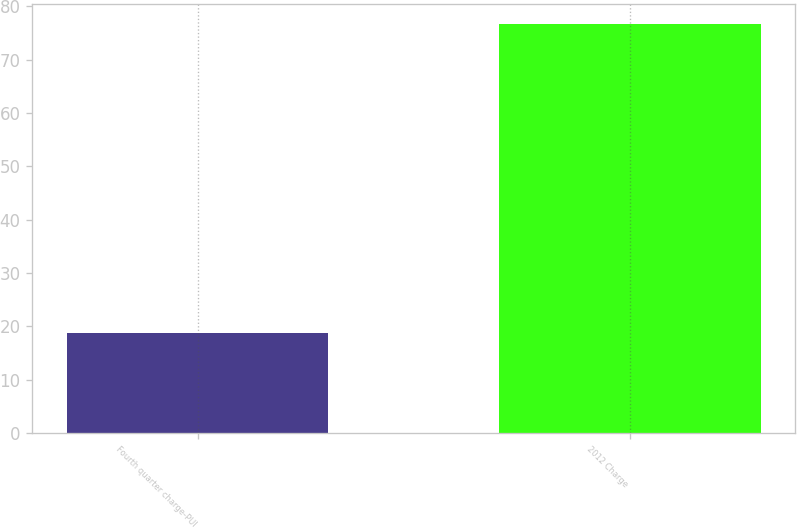Convert chart. <chart><loc_0><loc_0><loc_500><loc_500><bar_chart><fcel>Fourth quarter charge-PUI<fcel>2012 Charge<nl><fcel>18.8<fcel>76.6<nl></chart> 